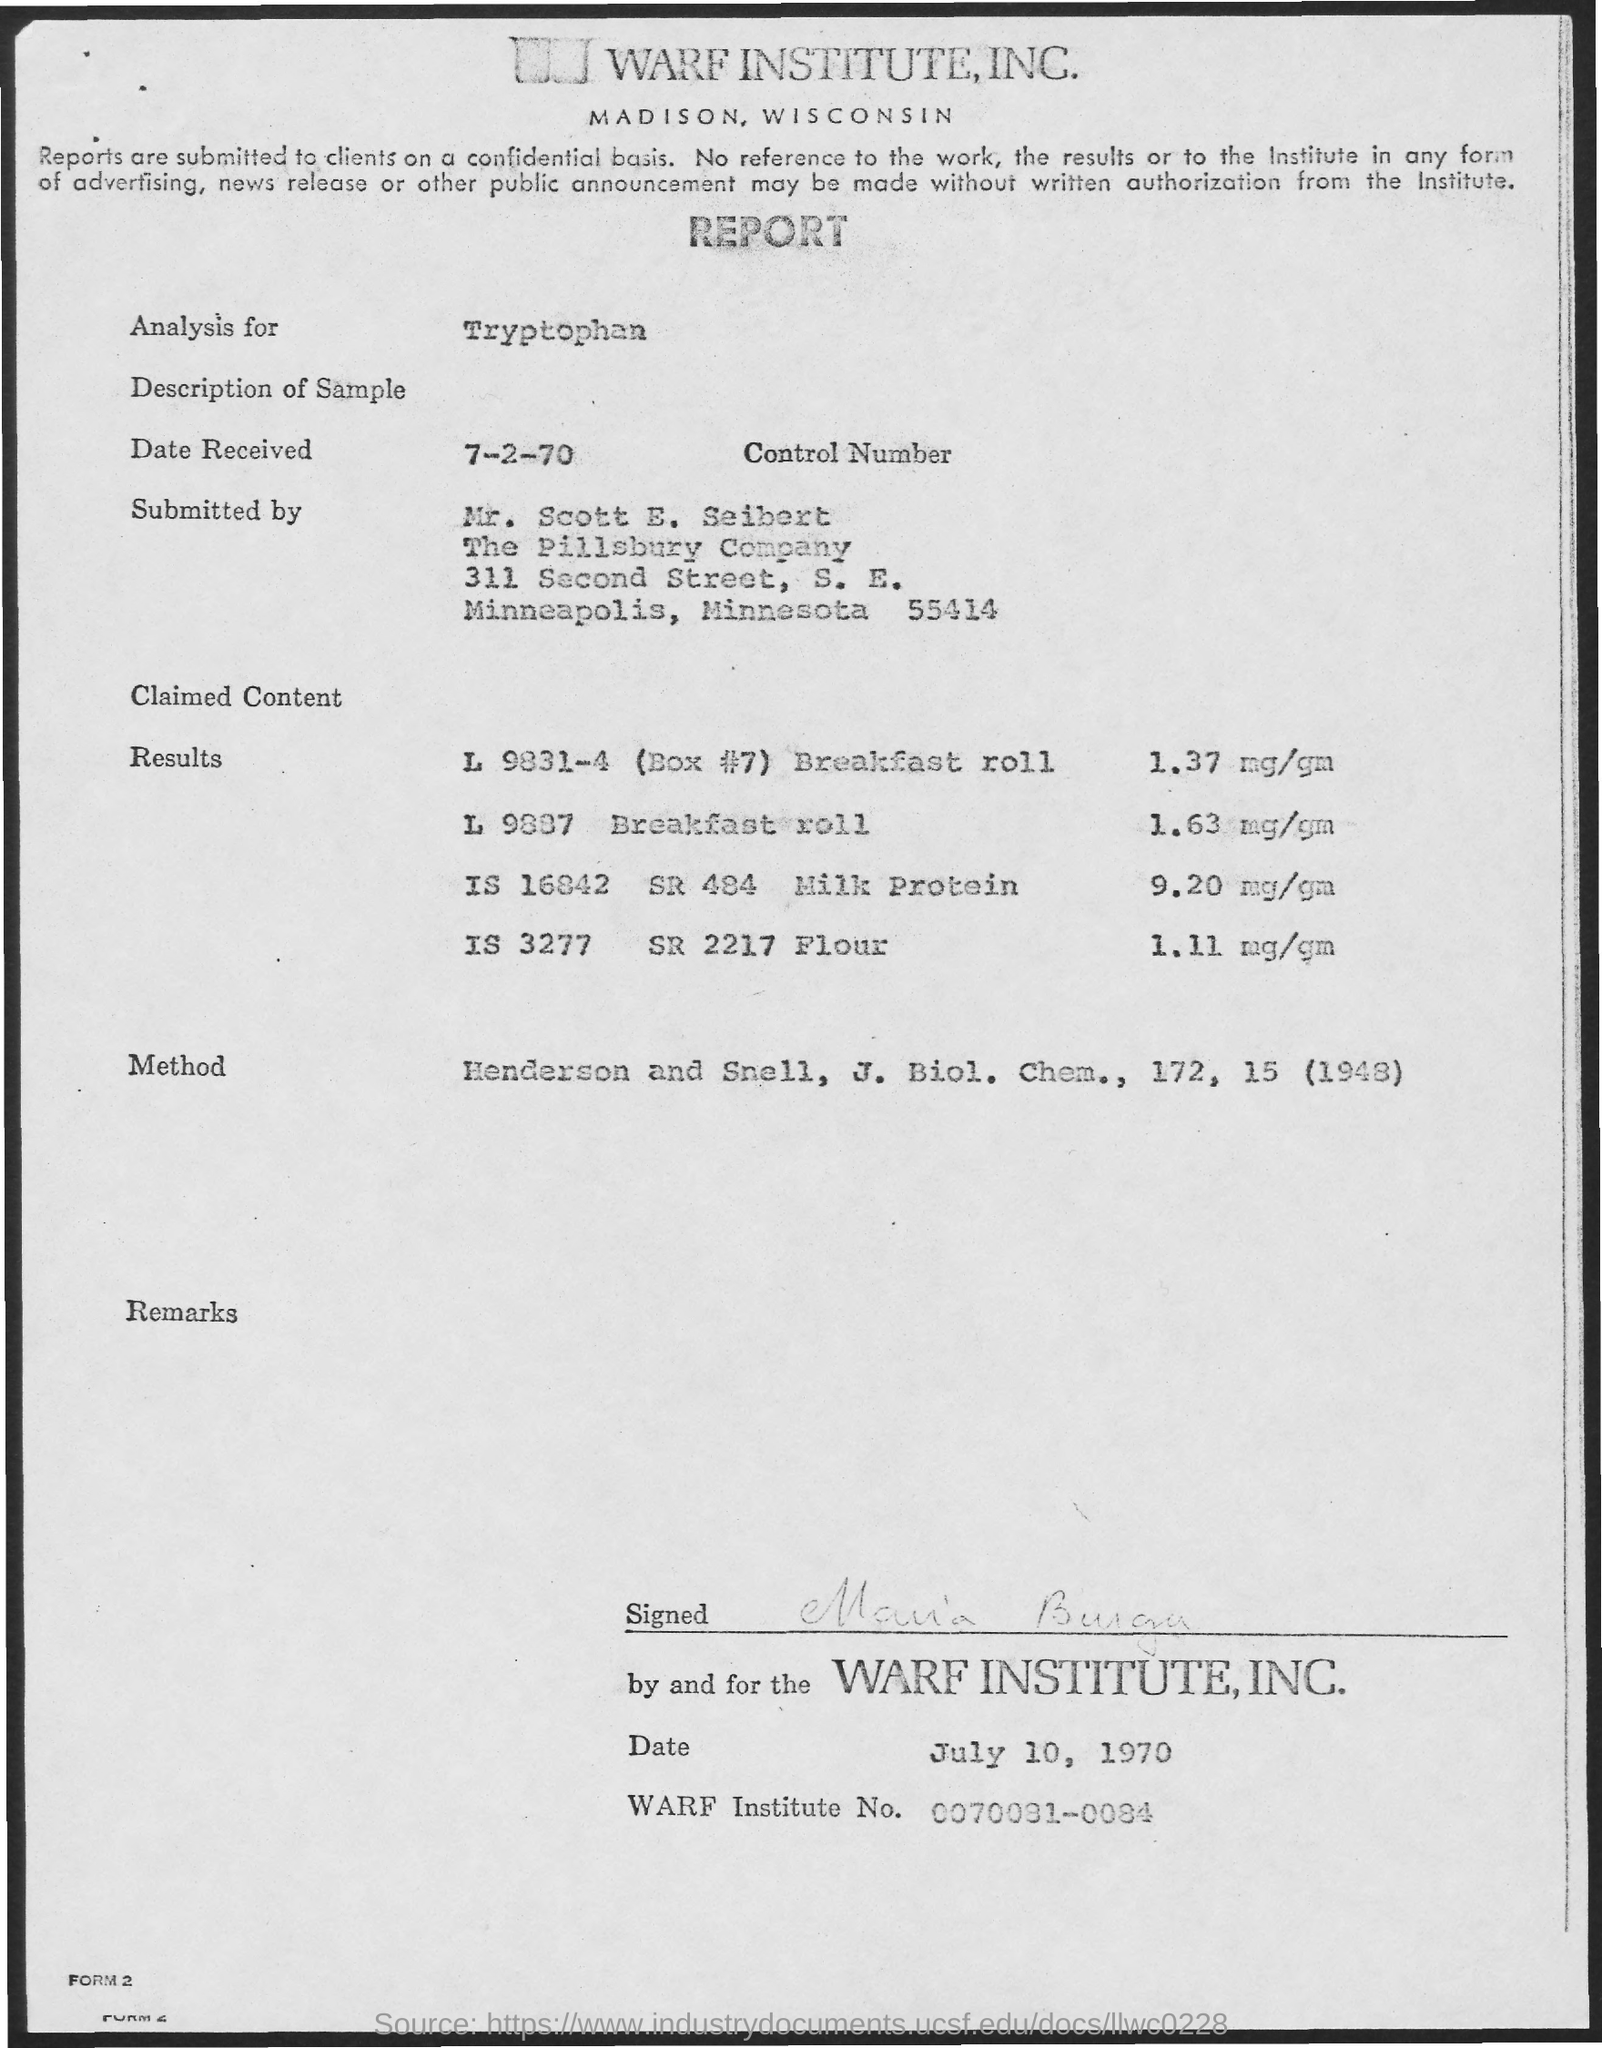What is the analysis for?
Your answer should be very brief. Tryptophan. What is the Date Received?
Offer a very short reply. 7-2-70. Who was it submitted by?
Provide a short and direct response. MR. SCOTT E. SEIBERT. Who is it signed by?
Your answer should be compact. Maria Burga. When was it signed?
Make the answer very short. July 10, 1970. What is the WARF Institute No.?
Ensure brevity in your answer.  0070081-0084. 